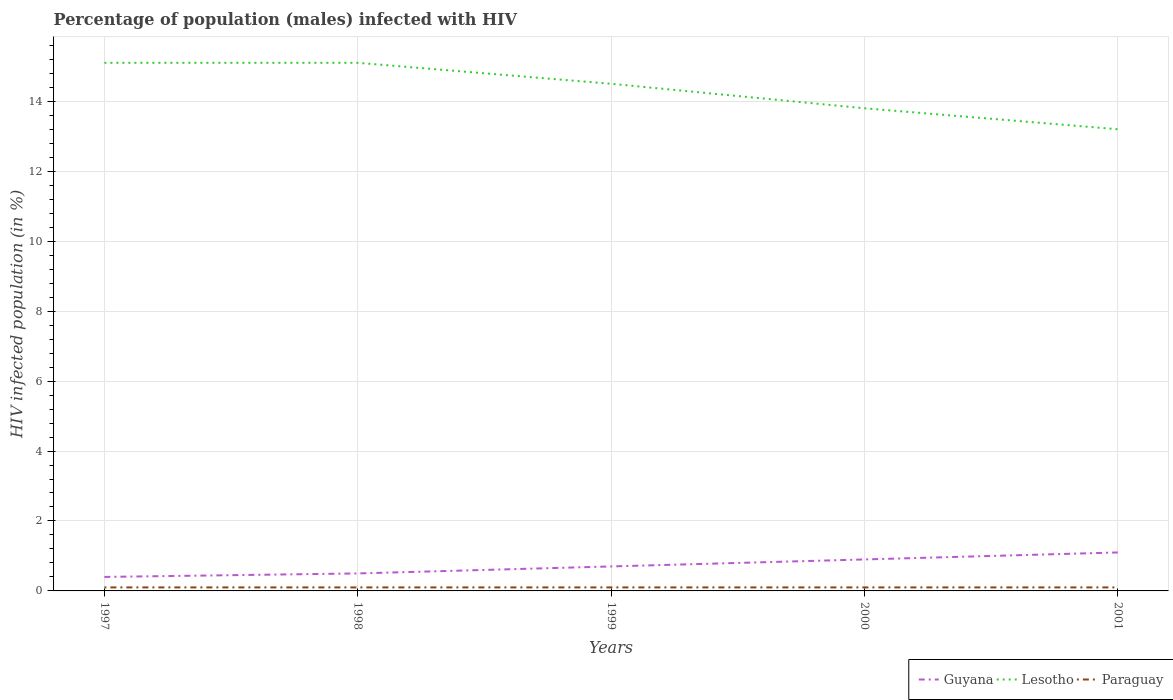Across all years, what is the maximum percentage of HIV infected male population in Lesotho?
Your response must be concise. 13.2. What is the total percentage of HIV infected male population in Lesotho in the graph?
Provide a short and direct response. 0.6. What is the difference between the highest and the second highest percentage of HIV infected male population in Lesotho?
Your answer should be compact. 1.9. Is the percentage of HIV infected male population in Guyana strictly greater than the percentage of HIV infected male population in Paraguay over the years?
Offer a terse response. No. How many lines are there?
Your response must be concise. 3. Does the graph contain grids?
Provide a short and direct response. Yes. Where does the legend appear in the graph?
Offer a very short reply. Bottom right. What is the title of the graph?
Offer a very short reply. Percentage of population (males) infected with HIV. What is the label or title of the X-axis?
Offer a very short reply. Years. What is the label or title of the Y-axis?
Your answer should be compact. HIV infected population (in %). What is the HIV infected population (in %) in Guyana in 1997?
Offer a terse response. 0.4. What is the HIV infected population (in %) in Paraguay in 1998?
Your answer should be compact. 0.1. What is the HIV infected population (in %) of Guyana in 1999?
Provide a short and direct response. 0.7. What is the HIV infected population (in %) of Paraguay in 1999?
Your answer should be very brief. 0.1. What is the HIV infected population (in %) of Paraguay in 2000?
Keep it short and to the point. 0.1. What is the HIV infected population (in %) of Guyana in 2001?
Offer a very short reply. 1.1. What is the HIV infected population (in %) of Lesotho in 2001?
Provide a succinct answer. 13.2. Across all years, what is the maximum HIV infected population (in %) in Paraguay?
Your answer should be very brief. 0.1. Across all years, what is the minimum HIV infected population (in %) of Guyana?
Your answer should be compact. 0.4. What is the total HIV infected population (in %) of Lesotho in the graph?
Your answer should be compact. 71.7. What is the difference between the HIV infected population (in %) of Guyana in 1997 and that in 1998?
Keep it short and to the point. -0.1. What is the difference between the HIV infected population (in %) in Paraguay in 1997 and that in 1998?
Your answer should be very brief. 0. What is the difference between the HIV infected population (in %) of Guyana in 1997 and that in 1999?
Offer a terse response. -0.3. What is the difference between the HIV infected population (in %) of Paraguay in 1997 and that in 1999?
Your answer should be very brief. 0. What is the difference between the HIV infected population (in %) of Guyana in 1997 and that in 2000?
Your answer should be very brief. -0.5. What is the difference between the HIV infected population (in %) of Lesotho in 1997 and that in 2000?
Ensure brevity in your answer.  1.3. What is the difference between the HIV infected population (in %) of Guyana in 1997 and that in 2001?
Keep it short and to the point. -0.7. What is the difference between the HIV infected population (in %) in Lesotho in 1997 and that in 2001?
Ensure brevity in your answer.  1.9. What is the difference between the HIV infected population (in %) in Paraguay in 1997 and that in 2001?
Provide a succinct answer. 0. What is the difference between the HIV infected population (in %) in Guyana in 1998 and that in 1999?
Offer a terse response. -0.2. What is the difference between the HIV infected population (in %) in Lesotho in 1998 and that in 1999?
Your response must be concise. 0.6. What is the difference between the HIV infected population (in %) in Paraguay in 1998 and that in 1999?
Your answer should be compact. 0. What is the difference between the HIV infected population (in %) in Lesotho in 1998 and that in 2000?
Your response must be concise. 1.3. What is the difference between the HIV infected population (in %) of Guyana in 1998 and that in 2001?
Give a very brief answer. -0.6. What is the difference between the HIV infected population (in %) in Lesotho in 1998 and that in 2001?
Offer a terse response. 1.9. What is the difference between the HIV infected population (in %) of Lesotho in 1999 and that in 2000?
Offer a very short reply. 0.7. What is the difference between the HIV infected population (in %) in Paraguay in 1999 and that in 2000?
Provide a short and direct response. 0. What is the difference between the HIV infected population (in %) in Lesotho in 1999 and that in 2001?
Give a very brief answer. 1.3. What is the difference between the HIV infected population (in %) of Guyana in 2000 and that in 2001?
Offer a very short reply. -0.2. What is the difference between the HIV infected population (in %) of Lesotho in 2000 and that in 2001?
Provide a succinct answer. 0.6. What is the difference between the HIV infected population (in %) of Guyana in 1997 and the HIV infected population (in %) of Lesotho in 1998?
Offer a terse response. -14.7. What is the difference between the HIV infected population (in %) of Lesotho in 1997 and the HIV infected population (in %) of Paraguay in 1998?
Ensure brevity in your answer.  15. What is the difference between the HIV infected population (in %) of Guyana in 1997 and the HIV infected population (in %) of Lesotho in 1999?
Offer a very short reply. -14.1. What is the difference between the HIV infected population (in %) of Guyana in 1997 and the HIV infected population (in %) of Paraguay in 1999?
Offer a very short reply. 0.3. What is the difference between the HIV infected population (in %) in Lesotho in 1997 and the HIV infected population (in %) in Paraguay in 1999?
Make the answer very short. 15. What is the difference between the HIV infected population (in %) in Guyana in 1998 and the HIV infected population (in %) in Paraguay in 1999?
Provide a succinct answer. 0.4. What is the difference between the HIV infected population (in %) in Lesotho in 1998 and the HIV infected population (in %) in Paraguay in 1999?
Provide a succinct answer. 15. What is the difference between the HIV infected population (in %) in Guyana in 1998 and the HIV infected population (in %) in Paraguay in 2000?
Offer a very short reply. 0.4. What is the difference between the HIV infected population (in %) in Lesotho in 1998 and the HIV infected population (in %) in Paraguay in 2001?
Provide a short and direct response. 15. What is the difference between the HIV infected population (in %) of Lesotho in 1999 and the HIV infected population (in %) of Paraguay in 2000?
Make the answer very short. 14.4. What is the difference between the HIV infected population (in %) in Guyana in 2000 and the HIV infected population (in %) in Lesotho in 2001?
Your answer should be very brief. -12.3. What is the difference between the HIV infected population (in %) of Lesotho in 2000 and the HIV infected population (in %) of Paraguay in 2001?
Offer a terse response. 13.7. What is the average HIV infected population (in %) of Guyana per year?
Your answer should be compact. 0.72. What is the average HIV infected population (in %) in Lesotho per year?
Offer a very short reply. 14.34. In the year 1997, what is the difference between the HIV infected population (in %) of Guyana and HIV infected population (in %) of Lesotho?
Offer a terse response. -14.7. In the year 1997, what is the difference between the HIV infected population (in %) of Guyana and HIV infected population (in %) of Paraguay?
Offer a very short reply. 0.3. In the year 1998, what is the difference between the HIV infected population (in %) of Guyana and HIV infected population (in %) of Lesotho?
Make the answer very short. -14.6. In the year 1998, what is the difference between the HIV infected population (in %) in Guyana and HIV infected population (in %) in Paraguay?
Ensure brevity in your answer.  0.4. In the year 1998, what is the difference between the HIV infected population (in %) of Lesotho and HIV infected population (in %) of Paraguay?
Keep it short and to the point. 15. In the year 1999, what is the difference between the HIV infected population (in %) in Lesotho and HIV infected population (in %) in Paraguay?
Ensure brevity in your answer.  14.4. In the year 2000, what is the difference between the HIV infected population (in %) of Guyana and HIV infected population (in %) of Lesotho?
Your answer should be very brief. -12.9. In the year 2000, what is the difference between the HIV infected population (in %) in Lesotho and HIV infected population (in %) in Paraguay?
Offer a terse response. 13.7. In the year 2001, what is the difference between the HIV infected population (in %) of Guyana and HIV infected population (in %) of Paraguay?
Offer a terse response. 1. What is the ratio of the HIV infected population (in %) of Paraguay in 1997 to that in 1998?
Keep it short and to the point. 1. What is the ratio of the HIV infected population (in %) of Guyana in 1997 to that in 1999?
Keep it short and to the point. 0.57. What is the ratio of the HIV infected population (in %) in Lesotho in 1997 to that in 1999?
Offer a very short reply. 1.04. What is the ratio of the HIV infected population (in %) in Guyana in 1997 to that in 2000?
Ensure brevity in your answer.  0.44. What is the ratio of the HIV infected population (in %) of Lesotho in 1997 to that in 2000?
Your response must be concise. 1.09. What is the ratio of the HIV infected population (in %) of Paraguay in 1997 to that in 2000?
Make the answer very short. 1. What is the ratio of the HIV infected population (in %) in Guyana in 1997 to that in 2001?
Provide a short and direct response. 0.36. What is the ratio of the HIV infected population (in %) in Lesotho in 1997 to that in 2001?
Ensure brevity in your answer.  1.14. What is the ratio of the HIV infected population (in %) of Paraguay in 1997 to that in 2001?
Ensure brevity in your answer.  1. What is the ratio of the HIV infected population (in %) of Guyana in 1998 to that in 1999?
Give a very brief answer. 0.71. What is the ratio of the HIV infected population (in %) in Lesotho in 1998 to that in 1999?
Make the answer very short. 1.04. What is the ratio of the HIV infected population (in %) in Paraguay in 1998 to that in 1999?
Keep it short and to the point. 1. What is the ratio of the HIV infected population (in %) in Guyana in 1998 to that in 2000?
Your response must be concise. 0.56. What is the ratio of the HIV infected population (in %) in Lesotho in 1998 to that in 2000?
Your answer should be very brief. 1.09. What is the ratio of the HIV infected population (in %) of Paraguay in 1998 to that in 2000?
Offer a terse response. 1. What is the ratio of the HIV infected population (in %) in Guyana in 1998 to that in 2001?
Your answer should be compact. 0.45. What is the ratio of the HIV infected population (in %) in Lesotho in 1998 to that in 2001?
Keep it short and to the point. 1.14. What is the ratio of the HIV infected population (in %) of Paraguay in 1998 to that in 2001?
Provide a succinct answer. 1. What is the ratio of the HIV infected population (in %) in Guyana in 1999 to that in 2000?
Your response must be concise. 0.78. What is the ratio of the HIV infected population (in %) in Lesotho in 1999 to that in 2000?
Your answer should be very brief. 1.05. What is the ratio of the HIV infected population (in %) in Paraguay in 1999 to that in 2000?
Offer a terse response. 1. What is the ratio of the HIV infected population (in %) in Guyana in 1999 to that in 2001?
Ensure brevity in your answer.  0.64. What is the ratio of the HIV infected population (in %) in Lesotho in 1999 to that in 2001?
Offer a terse response. 1.1. What is the ratio of the HIV infected population (in %) of Guyana in 2000 to that in 2001?
Your answer should be compact. 0.82. What is the ratio of the HIV infected population (in %) of Lesotho in 2000 to that in 2001?
Provide a succinct answer. 1.05. What is the difference between the highest and the second highest HIV infected population (in %) in Guyana?
Your response must be concise. 0.2. What is the difference between the highest and the second highest HIV infected population (in %) of Lesotho?
Your answer should be very brief. 0. What is the difference between the highest and the lowest HIV infected population (in %) in Lesotho?
Keep it short and to the point. 1.9. What is the difference between the highest and the lowest HIV infected population (in %) in Paraguay?
Offer a very short reply. 0. 